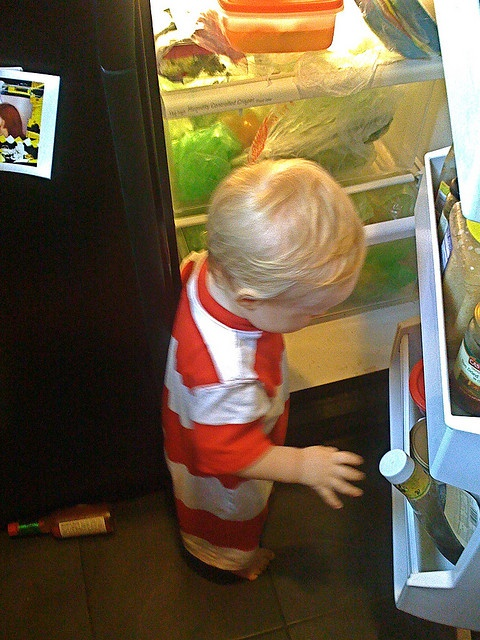Describe the objects in this image and their specific colors. I can see refrigerator in black, tan, olive, and gray tones, people in black, tan, gray, maroon, and brown tones, bottle in black, gray, and darkgreen tones, broccoli in black, olive, and lightgreen tones, and bowl in black, orange, and khaki tones in this image. 